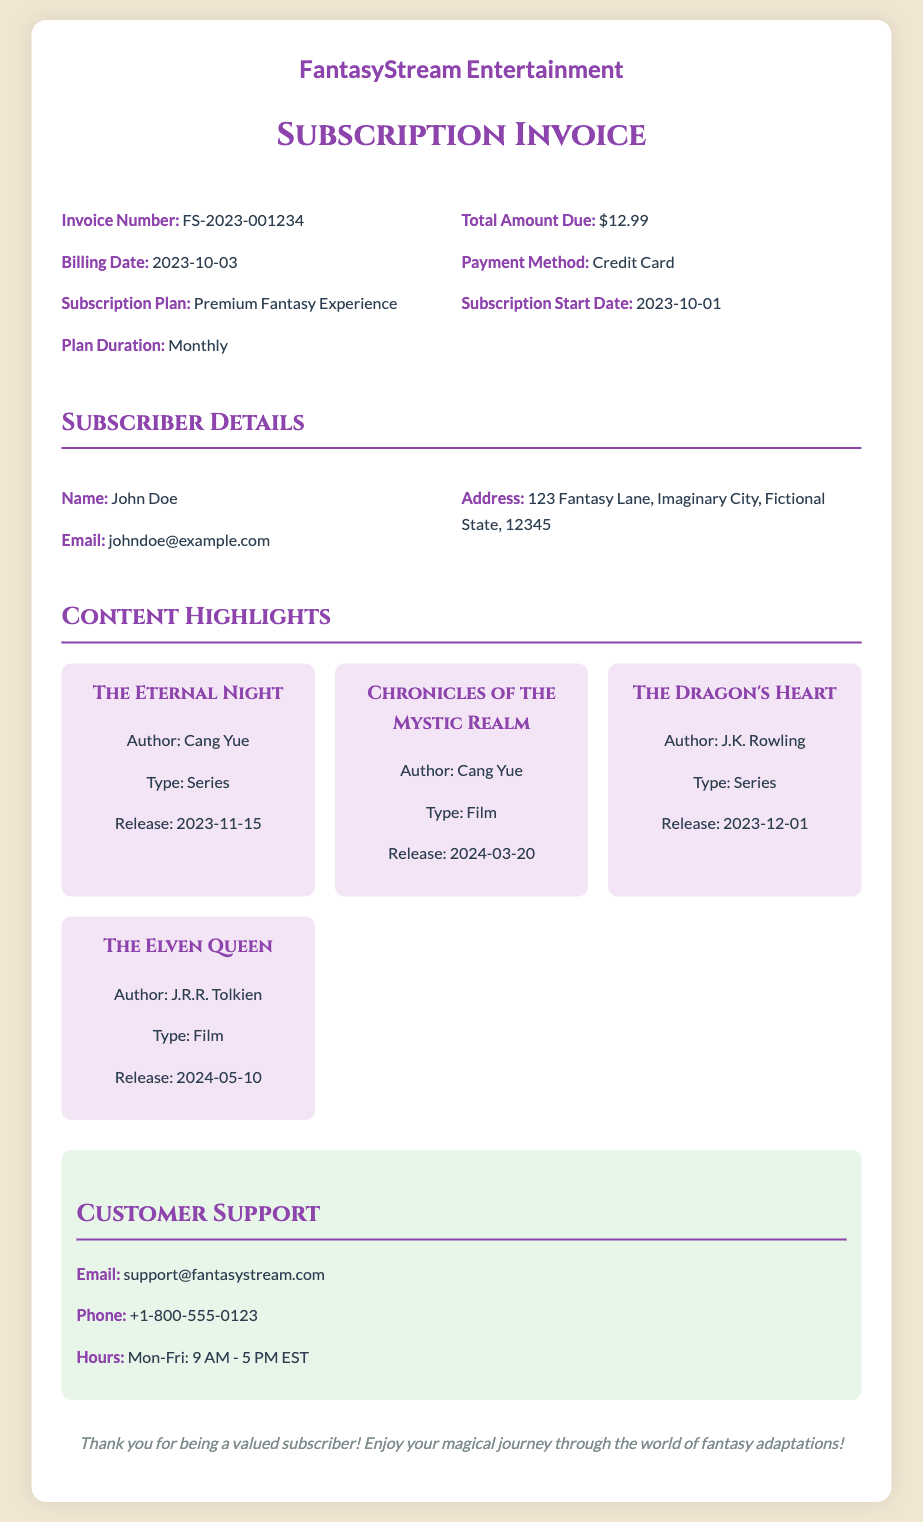What is the invoice number? The invoice number is a unique identifier for the transaction, listed clearly in the invoice section.
Answer: FS-2023-001234 What is the total amount due? The total amount due is the figure that needs to be paid by the subscriber, found in the invoice details.
Answer: $12.99 What is the name of the subscriber? The name of the subscriber is provided in the subscriber details section.
Answer: John Doe What is the release date of "The Eternal Night"? The release date for "The Eternal Night" is detailed in the content highlights section of the document.
Answer: 2023-11-15 What payment method was used? The payment method indicates how the subscriber chose to pay for the subscription, which is mentioned in the invoice details.
Answer: Credit Card What type of content is "Chronicles of the Mystic Realm"? The type of content specifies the format of the adaptation, either film or series, found in the content highlights.
Answer: Film What is the subscription start date? The subscription start date indicates when the subscriber's access to the service began, specified in the invoice details.
Answer: 2023-10-01 Which author has the most adaptations listed in the content highlights? This requires assessing the author contributions in the content highlights to determine which one has multiple entries.
Answer: Cang Yue What are the customer support hours? The customer support hours are provided in the customer support section of the document, outlining when help is available.
Answer: Mon-Fri: 9 AM - 5 PM EST 